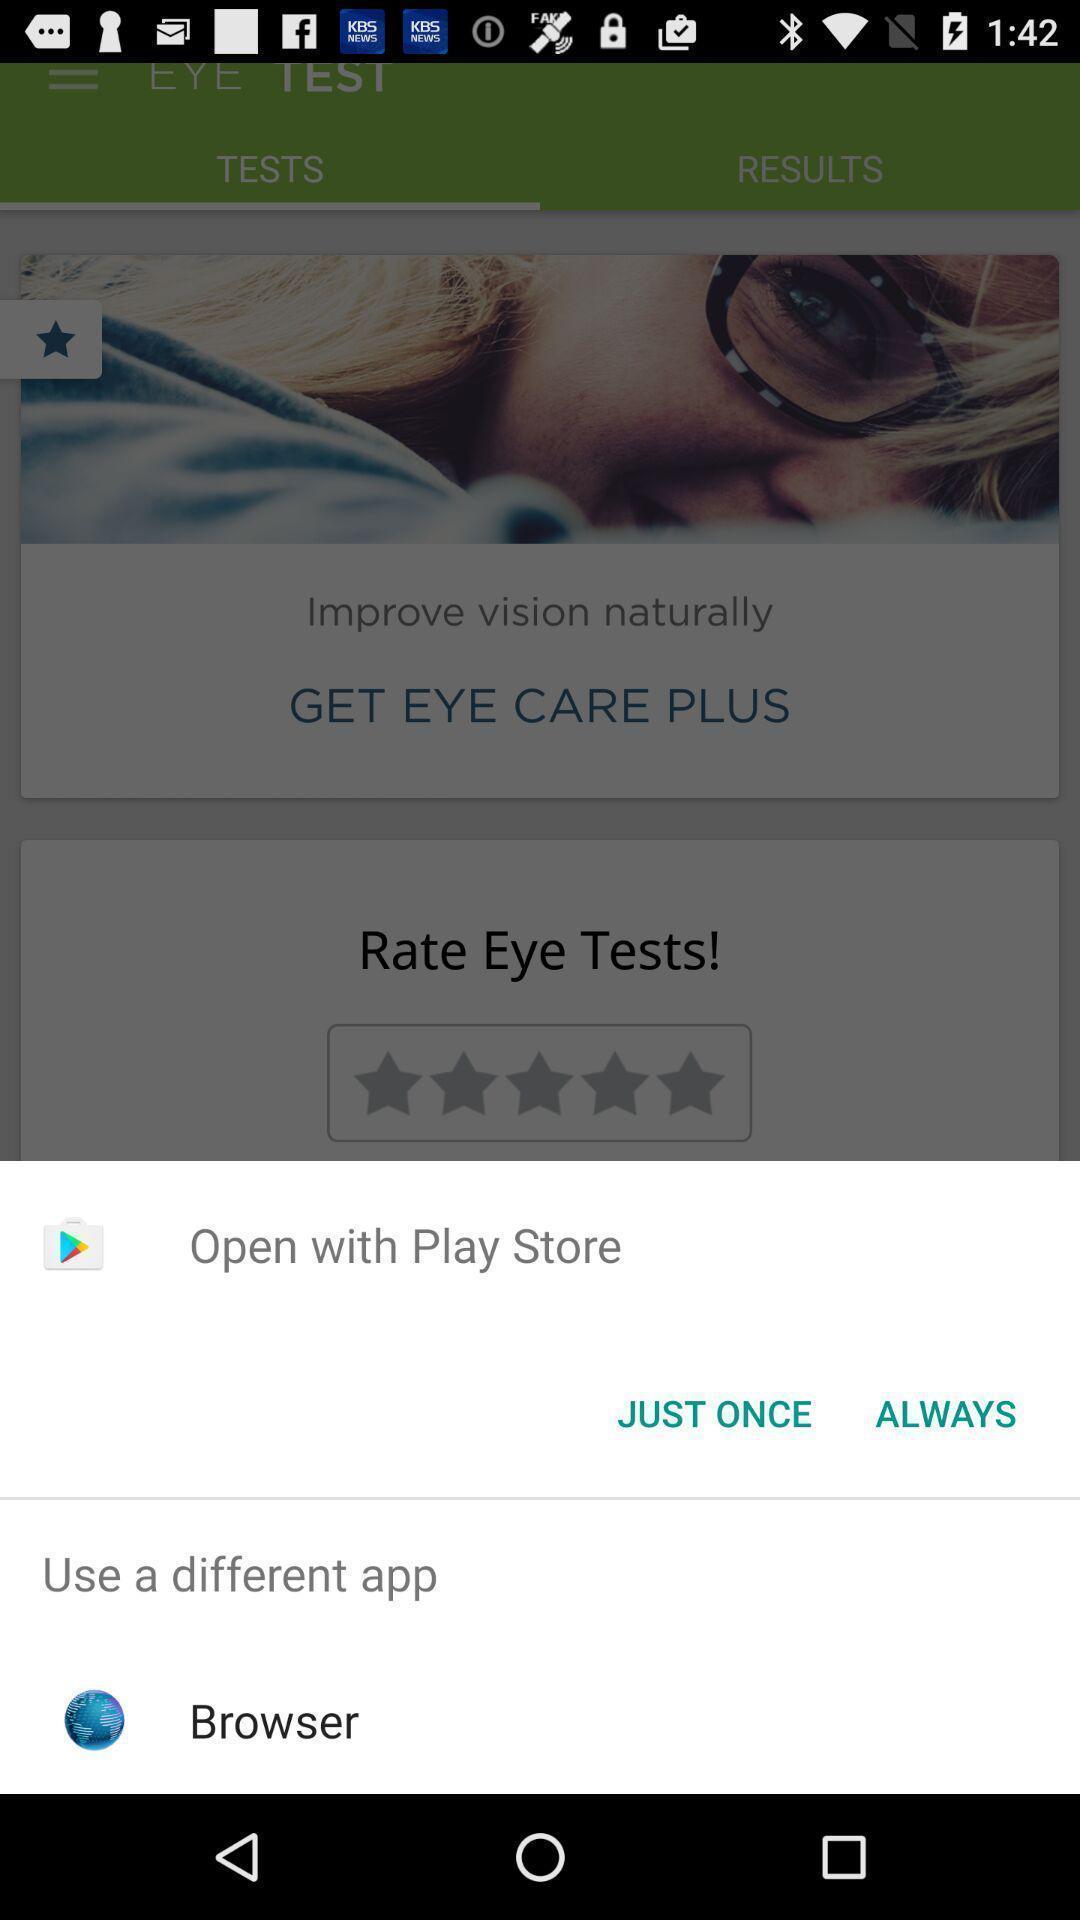Summarize the main components in this picture. Popup page to open through different apps. 